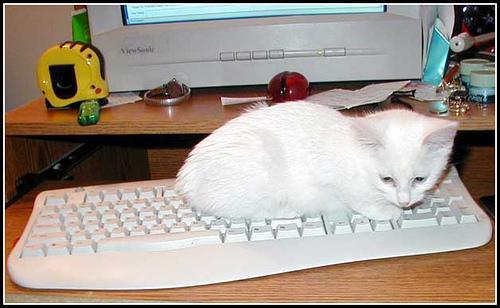How many green items do you see?
Give a very brief answer. 2. How many ears does the cat have?
Give a very brief answer. 2. 